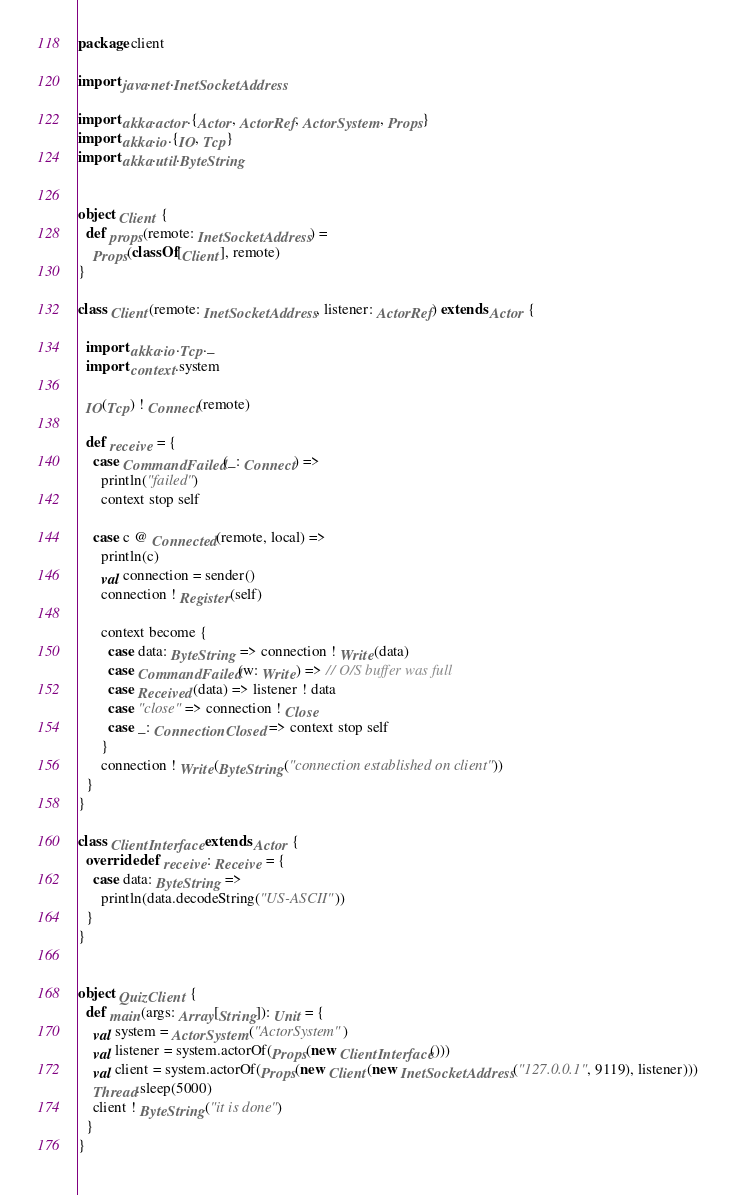<code> <loc_0><loc_0><loc_500><loc_500><_Scala_>package client

import java.net.InetSocketAddress

import akka.actor.{Actor, ActorRef, ActorSystem, Props}
import akka.io.{IO, Tcp}
import akka.util.ByteString


object Client {
  def props(remote: InetSocketAddress) =
    Props(classOf[Client], remote)
}

class Client(remote: InetSocketAddress, listener: ActorRef) extends Actor {

  import akka.io.Tcp._
  import context.system

  IO(Tcp) ! Connect(remote)

  def receive = {
    case CommandFailed(_: Connect) =>
      println("failed")
      context stop self

    case c @ Connected(remote, local) =>
      println(c)
      val connection = sender()
      connection ! Register(self)

      context become {
        case data: ByteString => connection ! Write(data)
        case CommandFailed(w: Write) => // O/S buffer was full
        case Received(data) => listener ! data
        case "close" => connection ! Close
        case _: ConnectionClosed => context stop self
      }
      connection ! Write(ByteString("connection established on client"))
  }
}

class ClientInterface extends Actor {
  override def receive: Receive = {
    case data: ByteString =>
      println(data.decodeString("US-ASCII"))
  }
}


object QuizClient {
  def main(args: Array[String]): Unit = {
    val system = ActorSystem("ActorSystem")
    val listener = system.actorOf(Props(new ClientInterface()))
    val client = system.actorOf(Props(new Client(new InetSocketAddress("127.0.0.1", 9119), listener)))
    Thread.sleep(5000)
    client ! ByteString("it is done")
  }
}



</code> 